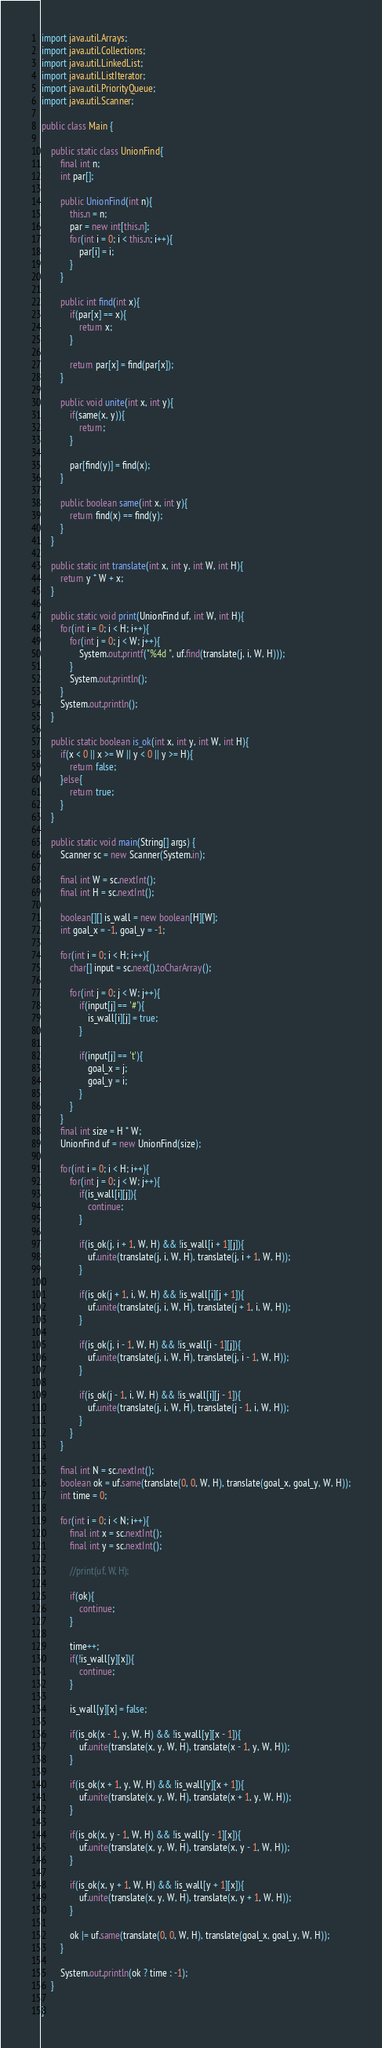Convert code to text. <code><loc_0><loc_0><loc_500><loc_500><_Java_>import java.util.Arrays;
import java.util.Collections;
import java.util.LinkedList;
import java.util.ListIterator;
import java.util.PriorityQueue;
import java.util.Scanner;

public class Main {
	
	public static class UnionFind{
		final int n;
		int par[];
		
		public UnionFind(int n){
			this.n = n;
			par = new int[this.n];
			for(int i = 0; i < this.n; i++){
				par[i] = i;
			}
		}
		
		public int find(int x){
			if(par[x] == x){
				return x;
			}
			
			return par[x] = find(par[x]);
		}
		
		public void unite(int x, int y){
			if(same(x, y)){
				return;
			}
			
			par[find(y)] = find(x);
		}
		
		public boolean same(int x, int y){
			return find(x) == find(y);
		}
	}
	
	public static int translate(int x, int y, int W, int H){
		return y * W + x;
	}
	
	public static void print(UnionFind uf, int W, int H){
		for(int i = 0; i < H; i++){
			for(int j = 0; j < W; j++){
				System.out.printf("%4d ", uf.find(translate(j, i, W, H)));
			}
			System.out.println();
		}
		System.out.println();
	}
	
	public static boolean is_ok(int x, int y, int W, int H){
		if(x < 0 || x >= W || y < 0 || y >= H){
			return false;
		}else{
			return true;
		}
	}
	
	public static void main(String[] args) {
		Scanner sc = new Scanner(System.in);
		
		final int W = sc.nextInt();
		final int H = sc.nextInt();
		
		boolean[][] is_wall = new boolean[H][W];
		int goal_x = -1, goal_y = -1;
		
		for(int i = 0; i < H; i++){
			char[] input = sc.next().toCharArray();
			
			for(int j = 0; j < W; j++){
				if(input[j] == '#'){
					is_wall[i][j] = true;
				}
				
				if(input[j] == 't'){
					goal_x = j;
					goal_y = i;
				}
			}
		}
		final int size = H * W;
		UnionFind uf = new UnionFind(size);
		
		for(int i = 0; i < H; i++){
			for(int j = 0; j < W; j++){
				if(is_wall[i][j]){
					continue;
				}
				
				if(is_ok(j, i + 1, W, H) && !is_wall[i + 1][j]){
					uf.unite(translate(j, i, W, H), translate(j, i + 1, W, H));
				}
				
				if(is_ok(j + 1, i, W, H) && !is_wall[i][j + 1]){
					uf.unite(translate(j, i, W, H), translate(j + 1, i, W, H));
				}
				
				if(is_ok(j, i - 1, W, H) && !is_wall[i - 1][j]){
					uf.unite(translate(j, i, W, H), translate(j, i - 1, W, H));
				}
				
				if(is_ok(j - 1, i, W, H) && !is_wall[i][j - 1]){
					uf.unite(translate(j, i, W, H), translate(j - 1, i, W, H));
				}
			}
		}
		
		final int N = sc.nextInt();
		boolean ok = uf.same(translate(0, 0, W, H), translate(goal_x, goal_y, W, H));
		int time = 0;
		
		for(int i = 0; i < N; i++){
			final int x = sc.nextInt();
			final int y = sc.nextInt();
			
			//print(uf, W, H);
			
			if(ok){
				continue;
			}
			
			time++;
			if(!is_wall[y][x]){
				continue;
			}
			
			is_wall[y][x] = false;
			
			if(is_ok(x - 1, y, W, H) && !is_wall[y][x - 1]){
				uf.unite(translate(x, y, W, H), translate(x - 1, y, W, H));
			}
			
			if(is_ok(x + 1, y, W, H) && !is_wall[y][x + 1]){
				uf.unite(translate(x, y, W, H), translate(x + 1, y, W, H));
			}
			
			if(is_ok(x, y - 1, W, H) && !is_wall[y - 1][x]){
				uf.unite(translate(x, y, W, H), translate(x, y - 1, W, H));
			}
			
			if(is_ok(x, y + 1, W, H) && !is_wall[y + 1][x]){
				uf.unite(translate(x, y, W, H), translate(x, y + 1, W, H));
			}
			
			ok |= uf.same(translate(0, 0, W, H), translate(goal_x, goal_y, W, H));
		}
		
		System.out.println(ok ? time : -1);
	}

}</code> 